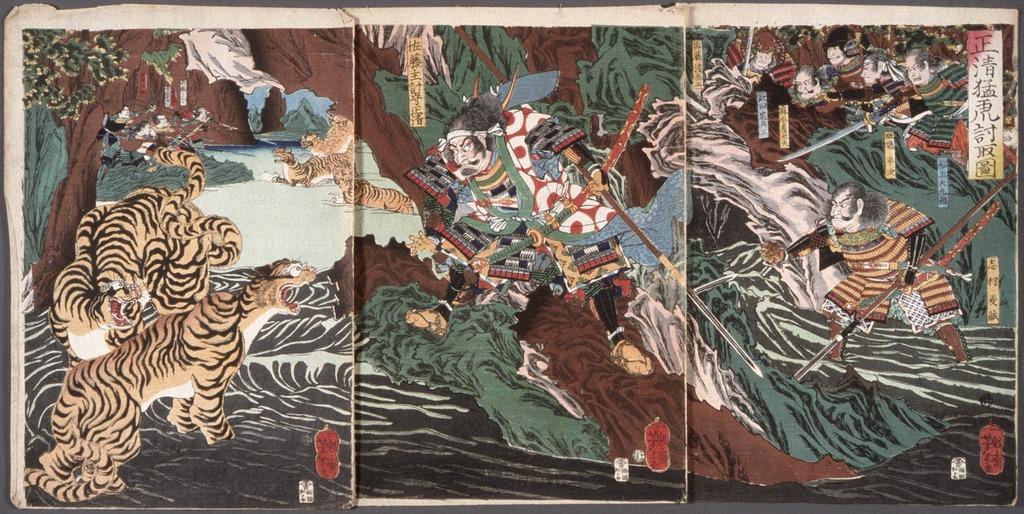Can you describe this image briefly? In this image, we can see three papers with images on the black color object. In these images, we can see people, weapons, animals and some objects. 